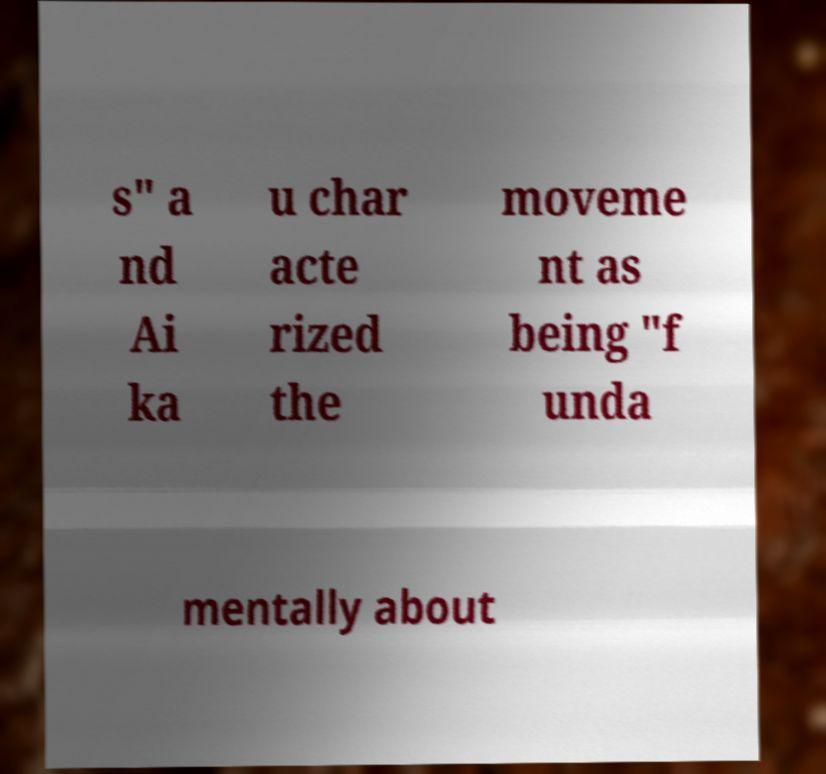Could you assist in decoding the text presented in this image and type it out clearly? s" a nd Ai ka u char acte rized the moveme nt as being "f unda mentally about 